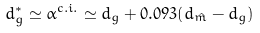<formula> <loc_0><loc_0><loc_500><loc_500>d ^ { * } _ { g } \simeq \alpha ^ { c . i . } \simeq d _ { g } + 0 . 0 9 3 ( d _ { \hat { m } } - d _ { g } )</formula> 